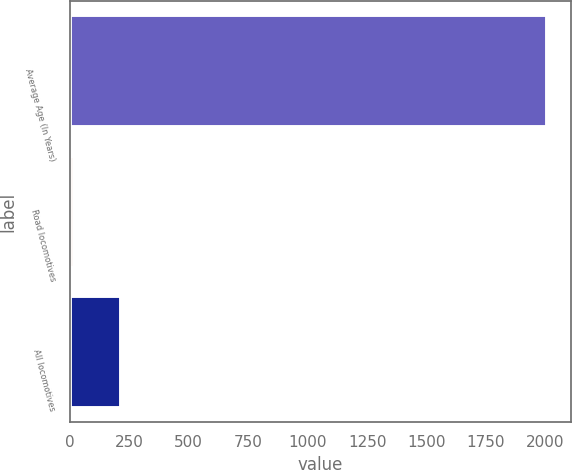Convert chart to OTSL. <chart><loc_0><loc_0><loc_500><loc_500><bar_chart><fcel>Average Age (In Years)<fcel>Road locomotives<fcel>All locomotives<nl><fcel>2007<fcel>15.7<fcel>214.83<nl></chart> 